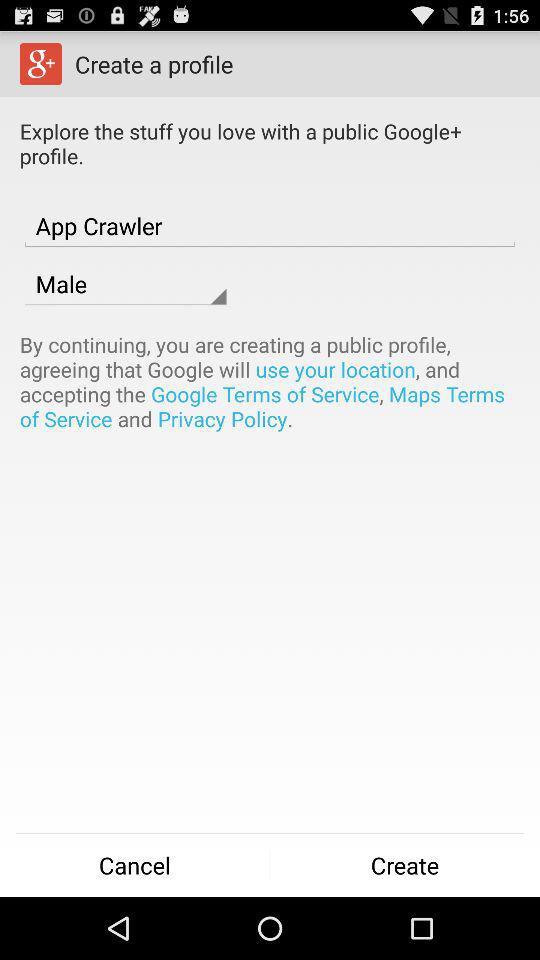What is the selected gender? The selected gender is male. 